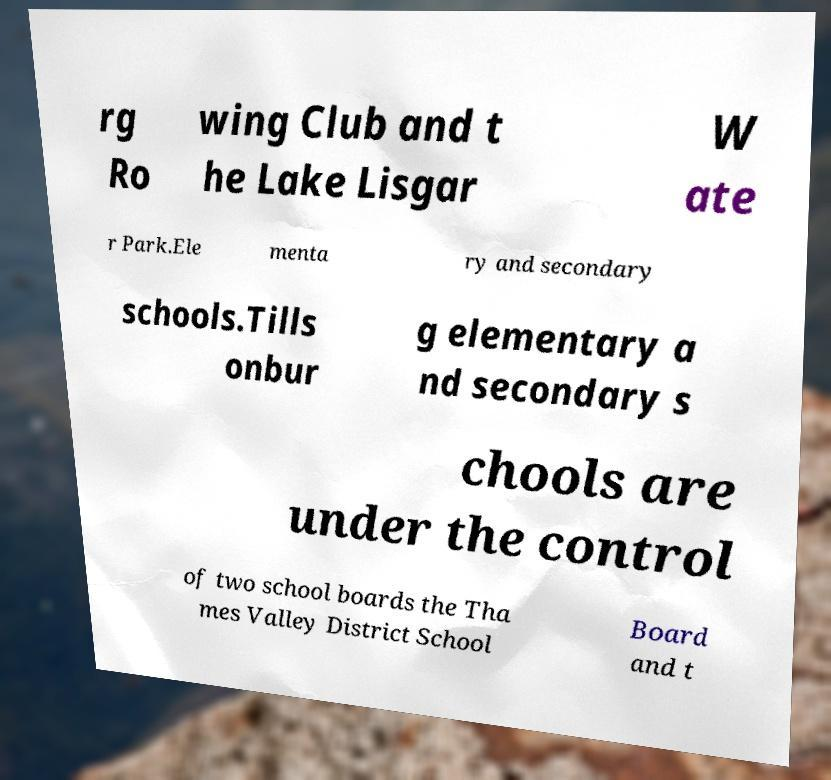Could you assist in decoding the text presented in this image and type it out clearly? rg Ro wing Club and t he Lake Lisgar W ate r Park.Ele menta ry and secondary schools.Tills onbur g elementary a nd secondary s chools are under the control of two school boards the Tha mes Valley District School Board and t 